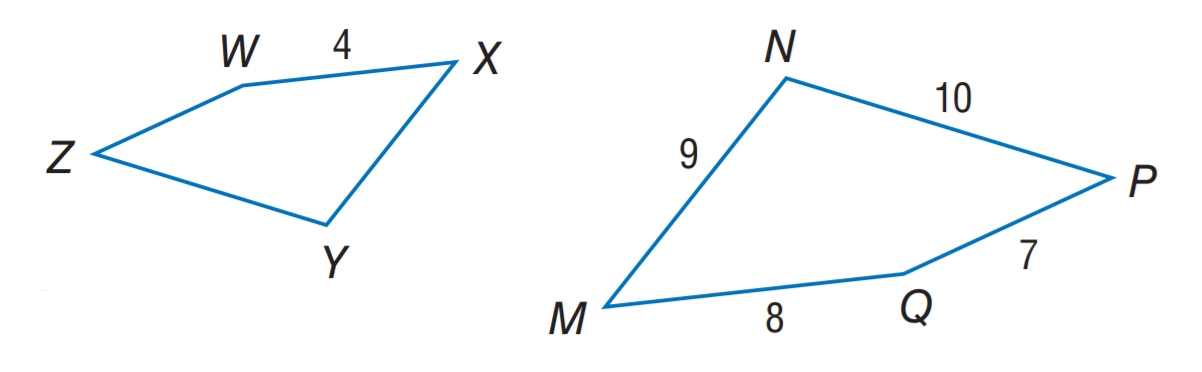Answer the mathemtical geometry problem and directly provide the correct option letter.
Question: If M N P Q \sim X Y Z W, find the scale factor of M N P Q to X Y Z W.
Choices: A: 2 B: 3 C: 4 D: 7 A 